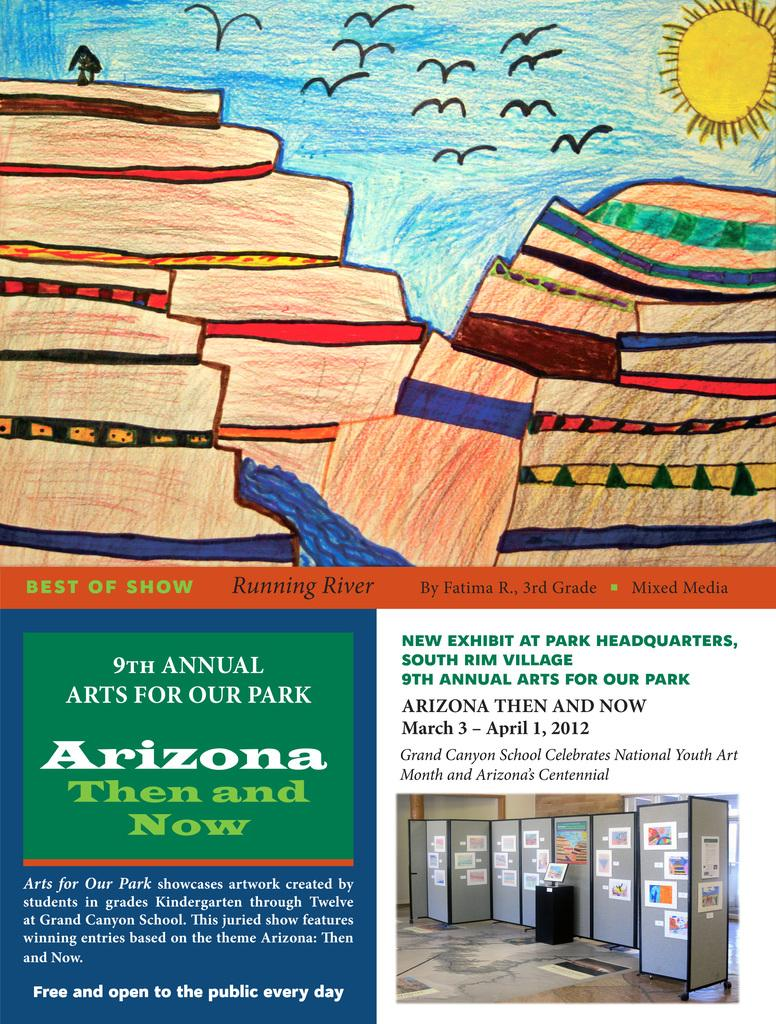Provide a one-sentence caption for the provided image. A crayon drawing of a valley and river displayed at teh 9th Annual Arts For Our Park exhibition. 